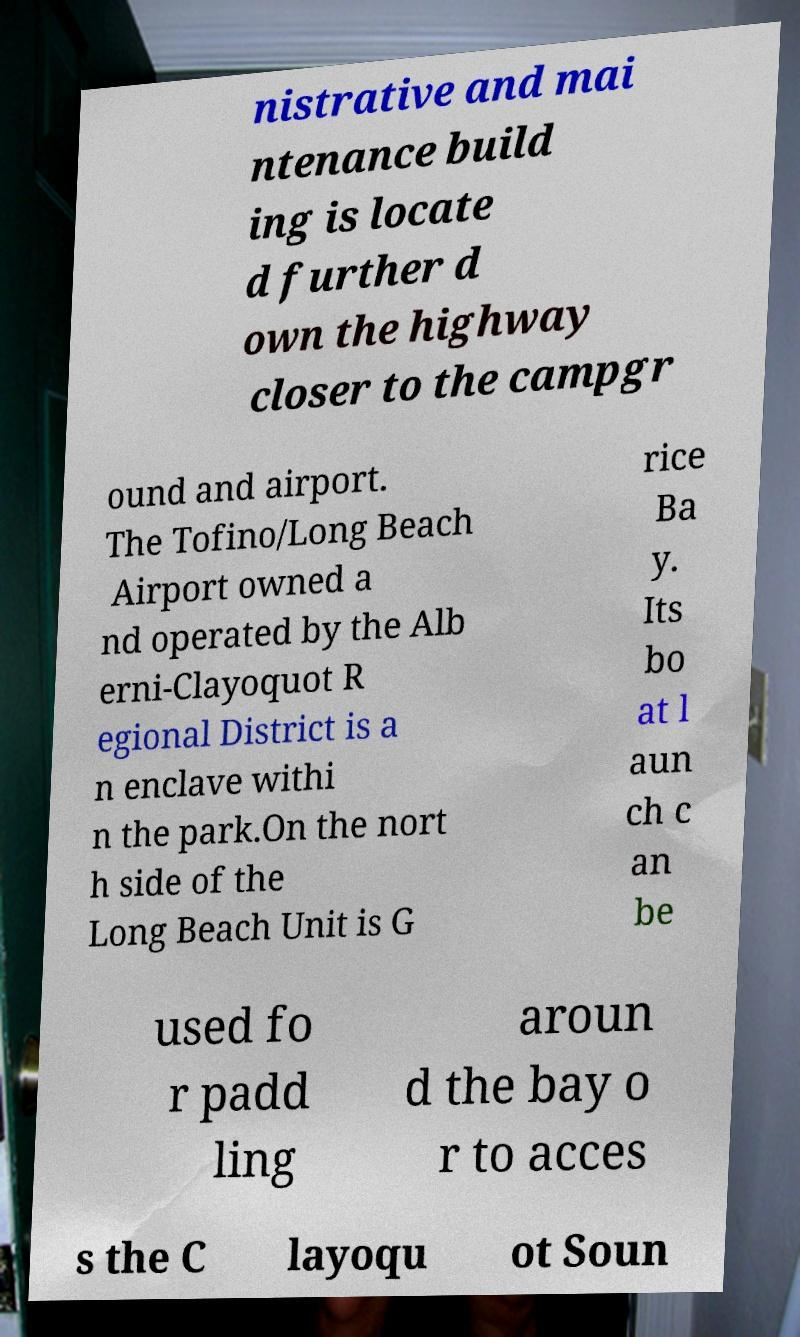Could you assist in decoding the text presented in this image and type it out clearly? nistrative and mai ntenance build ing is locate d further d own the highway closer to the campgr ound and airport. The Tofino/Long Beach Airport owned a nd operated by the Alb erni-Clayoquot R egional District is a n enclave withi n the park.On the nort h side of the Long Beach Unit is G rice Ba y. Its bo at l aun ch c an be used fo r padd ling aroun d the bay o r to acces s the C layoqu ot Soun 